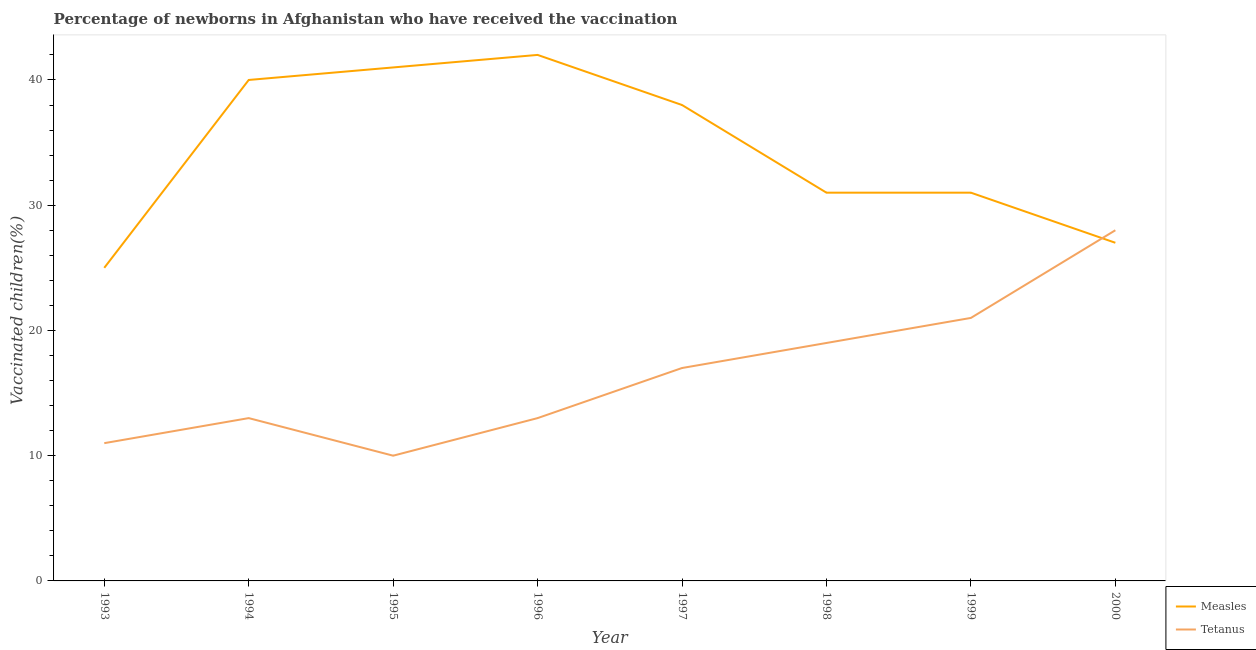Does the line corresponding to percentage of newborns who received vaccination for tetanus intersect with the line corresponding to percentage of newborns who received vaccination for measles?
Make the answer very short. Yes. Is the number of lines equal to the number of legend labels?
Ensure brevity in your answer.  Yes. What is the percentage of newborns who received vaccination for measles in 1999?
Ensure brevity in your answer.  31. Across all years, what is the maximum percentage of newborns who received vaccination for tetanus?
Offer a terse response. 28. Across all years, what is the minimum percentage of newborns who received vaccination for measles?
Give a very brief answer. 25. What is the total percentage of newborns who received vaccination for tetanus in the graph?
Offer a terse response. 132. What is the difference between the percentage of newborns who received vaccination for measles in 1993 and that in 1997?
Ensure brevity in your answer.  -13. What is the difference between the percentage of newborns who received vaccination for measles in 1993 and the percentage of newborns who received vaccination for tetanus in 2000?
Provide a succinct answer. -3. What is the average percentage of newborns who received vaccination for tetanus per year?
Offer a very short reply. 16.5. In the year 1994, what is the difference between the percentage of newborns who received vaccination for measles and percentage of newborns who received vaccination for tetanus?
Give a very brief answer. 27. What is the ratio of the percentage of newborns who received vaccination for tetanus in 1994 to that in 1996?
Give a very brief answer. 1. Is the difference between the percentage of newborns who received vaccination for measles in 1994 and 1995 greater than the difference between the percentage of newborns who received vaccination for tetanus in 1994 and 1995?
Offer a terse response. No. What is the difference between the highest and the second highest percentage of newborns who received vaccination for tetanus?
Your answer should be very brief. 7. What is the difference between the highest and the lowest percentage of newborns who received vaccination for tetanus?
Your response must be concise. 18. Is the sum of the percentage of newborns who received vaccination for tetanus in 1998 and 1999 greater than the maximum percentage of newborns who received vaccination for measles across all years?
Give a very brief answer. No. Does the percentage of newborns who received vaccination for measles monotonically increase over the years?
Keep it short and to the point. No. How many years are there in the graph?
Ensure brevity in your answer.  8. What is the difference between two consecutive major ticks on the Y-axis?
Make the answer very short. 10. Does the graph contain any zero values?
Give a very brief answer. No. How many legend labels are there?
Keep it short and to the point. 2. How are the legend labels stacked?
Your response must be concise. Vertical. What is the title of the graph?
Your answer should be very brief. Percentage of newborns in Afghanistan who have received the vaccination. Does "Male labourers" appear as one of the legend labels in the graph?
Ensure brevity in your answer.  No. What is the label or title of the Y-axis?
Provide a short and direct response. Vaccinated children(%)
. What is the Vaccinated children(%)
 in Measles in 1993?
Your response must be concise. 25. What is the Vaccinated children(%)
 in Tetanus in 1994?
Your response must be concise. 13. What is the Vaccinated children(%)
 in Measles in 1995?
Give a very brief answer. 41. What is the Vaccinated children(%)
 of Tetanus in 1995?
Your answer should be compact. 10. What is the Vaccinated children(%)
 of Tetanus in 1996?
Offer a terse response. 13. What is the Vaccinated children(%)
 in Measles in 1997?
Provide a succinct answer. 38. What is the Vaccinated children(%)
 of Measles in 1998?
Your response must be concise. 31. What is the Vaccinated children(%)
 in Tetanus in 1998?
Provide a succinct answer. 19. What is the Vaccinated children(%)
 in Measles in 1999?
Your response must be concise. 31. What is the Vaccinated children(%)
 of Tetanus in 1999?
Provide a short and direct response. 21. What is the Vaccinated children(%)
 in Measles in 2000?
Ensure brevity in your answer.  27. Across all years, what is the maximum Vaccinated children(%)
 of Measles?
Your answer should be very brief. 42. Across all years, what is the minimum Vaccinated children(%)
 in Tetanus?
Give a very brief answer. 10. What is the total Vaccinated children(%)
 in Measles in the graph?
Give a very brief answer. 275. What is the total Vaccinated children(%)
 of Tetanus in the graph?
Keep it short and to the point. 132. What is the difference between the Vaccinated children(%)
 in Tetanus in 1993 and that in 1994?
Give a very brief answer. -2. What is the difference between the Vaccinated children(%)
 in Tetanus in 1993 and that in 1995?
Give a very brief answer. 1. What is the difference between the Vaccinated children(%)
 of Tetanus in 1993 and that in 1997?
Your answer should be compact. -6. What is the difference between the Vaccinated children(%)
 of Measles in 1993 and that in 1998?
Offer a very short reply. -6. What is the difference between the Vaccinated children(%)
 of Measles in 1994 and that in 1995?
Give a very brief answer. -1. What is the difference between the Vaccinated children(%)
 in Measles in 1994 and that in 1996?
Give a very brief answer. -2. What is the difference between the Vaccinated children(%)
 of Tetanus in 1994 and that in 1996?
Ensure brevity in your answer.  0. What is the difference between the Vaccinated children(%)
 in Measles in 1994 and that in 1997?
Your response must be concise. 2. What is the difference between the Vaccinated children(%)
 in Tetanus in 1994 and that in 1997?
Make the answer very short. -4. What is the difference between the Vaccinated children(%)
 in Measles in 1994 and that in 1998?
Ensure brevity in your answer.  9. What is the difference between the Vaccinated children(%)
 of Tetanus in 1994 and that in 1998?
Provide a short and direct response. -6. What is the difference between the Vaccinated children(%)
 of Tetanus in 1994 and that in 1999?
Provide a succinct answer. -8. What is the difference between the Vaccinated children(%)
 in Measles in 1994 and that in 2000?
Your answer should be compact. 13. What is the difference between the Vaccinated children(%)
 of Tetanus in 1995 and that in 1996?
Make the answer very short. -3. What is the difference between the Vaccinated children(%)
 of Measles in 1995 and that in 1998?
Ensure brevity in your answer.  10. What is the difference between the Vaccinated children(%)
 in Tetanus in 1995 and that in 1998?
Make the answer very short. -9. What is the difference between the Vaccinated children(%)
 of Tetanus in 1995 and that in 1999?
Your response must be concise. -11. What is the difference between the Vaccinated children(%)
 of Measles in 1995 and that in 2000?
Provide a succinct answer. 14. What is the difference between the Vaccinated children(%)
 of Measles in 1996 and that in 1997?
Make the answer very short. 4. What is the difference between the Vaccinated children(%)
 in Tetanus in 1996 and that in 1997?
Keep it short and to the point. -4. What is the difference between the Vaccinated children(%)
 in Measles in 1996 and that in 1998?
Provide a short and direct response. 11. What is the difference between the Vaccinated children(%)
 of Tetanus in 1996 and that in 1998?
Your answer should be compact. -6. What is the difference between the Vaccinated children(%)
 of Measles in 1996 and that in 1999?
Your answer should be compact. 11. What is the difference between the Vaccinated children(%)
 of Tetanus in 1996 and that in 1999?
Your answer should be compact. -8. What is the difference between the Vaccinated children(%)
 in Measles in 1996 and that in 2000?
Give a very brief answer. 15. What is the difference between the Vaccinated children(%)
 of Tetanus in 1996 and that in 2000?
Your answer should be very brief. -15. What is the difference between the Vaccinated children(%)
 of Measles in 1997 and that in 1998?
Keep it short and to the point. 7. What is the difference between the Vaccinated children(%)
 of Tetanus in 1997 and that in 1998?
Your response must be concise. -2. What is the difference between the Vaccinated children(%)
 in Measles in 1997 and that in 1999?
Your answer should be compact. 7. What is the difference between the Vaccinated children(%)
 in Tetanus in 1997 and that in 1999?
Provide a succinct answer. -4. What is the difference between the Vaccinated children(%)
 of Measles in 1997 and that in 2000?
Ensure brevity in your answer.  11. What is the difference between the Vaccinated children(%)
 in Tetanus in 1997 and that in 2000?
Ensure brevity in your answer.  -11. What is the difference between the Vaccinated children(%)
 of Measles in 1998 and that in 1999?
Your answer should be compact. 0. What is the difference between the Vaccinated children(%)
 of Tetanus in 1998 and that in 1999?
Provide a short and direct response. -2. What is the difference between the Vaccinated children(%)
 of Tetanus in 1998 and that in 2000?
Keep it short and to the point. -9. What is the difference between the Vaccinated children(%)
 of Tetanus in 1999 and that in 2000?
Make the answer very short. -7. What is the difference between the Vaccinated children(%)
 of Measles in 1993 and the Vaccinated children(%)
 of Tetanus in 1994?
Ensure brevity in your answer.  12. What is the difference between the Vaccinated children(%)
 in Measles in 1994 and the Vaccinated children(%)
 in Tetanus in 1996?
Your response must be concise. 27. What is the difference between the Vaccinated children(%)
 of Measles in 1994 and the Vaccinated children(%)
 of Tetanus in 1997?
Your response must be concise. 23. What is the difference between the Vaccinated children(%)
 in Measles in 1994 and the Vaccinated children(%)
 in Tetanus in 1998?
Make the answer very short. 21. What is the difference between the Vaccinated children(%)
 in Measles in 1994 and the Vaccinated children(%)
 in Tetanus in 1999?
Your answer should be compact. 19. What is the difference between the Vaccinated children(%)
 of Measles in 1994 and the Vaccinated children(%)
 of Tetanus in 2000?
Provide a short and direct response. 12. What is the difference between the Vaccinated children(%)
 in Measles in 1995 and the Vaccinated children(%)
 in Tetanus in 1998?
Keep it short and to the point. 22. What is the difference between the Vaccinated children(%)
 in Measles in 1995 and the Vaccinated children(%)
 in Tetanus in 2000?
Provide a succinct answer. 13. What is the difference between the Vaccinated children(%)
 in Measles in 1996 and the Vaccinated children(%)
 in Tetanus in 1997?
Provide a short and direct response. 25. What is the difference between the Vaccinated children(%)
 in Measles in 1996 and the Vaccinated children(%)
 in Tetanus in 1998?
Your response must be concise. 23. What is the difference between the Vaccinated children(%)
 of Measles in 1997 and the Vaccinated children(%)
 of Tetanus in 1998?
Make the answer very short. 19. What is the difference between the Vaccinated children(%)
 in Measles in 1998 and the Vaccinated children(%)
 in Tetanus in 1999?
Your answer should be compact. 10. What is the average Vaccinated children(%)
 in Measles per year?
Offer a terse response. 34.38. What is the average Vaccinated children(%)
 in Tetanus per year?
Make the answer very short. 16.5. In the year 1995, what is the difference between the Vaccinated children(%)
 of Measles and Vaccinated children(%)
 of Tetanus?
Your answer should be compact. 31. In the year 1996, what is the difference between the Vaccinated children(%)
 in Measles and Vaccinated children(%)
 in Tetanus?
Your answer should be very brief. 29. In the year 1997, what is the difference between the Vaccinated children(%)
 of Measles and Vaccinated children(%)
 of Tetanus?
Make the answer very short. 21. What is the ratio of the Vaccinated children(%)
 in Tetanus in 1993 to that in 1994?
Offer a terse response. 0.85. What is the ratio of the Vaccinated children(%)
 of Measles in 1993 to that in 1995?
Ensure brevity in your answer.  0.61. What is the ratio of the Vaccinated children(%)
 in Measles in 1993 to that in 1996?
Your answer should be very brief. 0.6. What is the ratio of the Vaccinated children(%)
 in Tetanus in 1993 to that in 1996?
Provide a short and direct response. 0.85. What is the ratio of the Vaccinated children(%)
 in Measles in 1993 to that in 1997?
Your response must be concise. 0.66. What is the ratio of the Vaccinated children(%)
 of Tetanus in 1993 to that in 1997?
Ensure brevity in your answer.  0.65. What is the ratio of the Vaccinated children(%)
 of Measles in 1993 to that in 1998?
Make the answer very short. 0.81. What is the ratio of the Vaccinated children(%)
 in Tetanus in 1993 to that in 1998?
Make the answer very short. 0.58. What is the ratio of the Vaccinated children(%)
 in Measles in 1993 to that in 1999?
Your response must be concise. 0.81. What is the ratio of the Vaccinated children(%)
 of Tetanus in 1993 to that in 1999?
Your answer should be compact. 0.52. What is the ratio of the Vaccinated children(%)
 of Measles in 1993 to that in 2000?
Provide a short and direct response. 0.93. What is the ratio of the Vaccinated children(%)
 of Tetanus in 1993 to that in 2000?
Provide a succinct answer. 0.39. What is the ratio of the Vaccinated children(%)
 in Measles in 1994 to that in 1995?
Ensure brevity in your answer.  0.98. What is the ratio of the Vaccinated children(%)
 of Tetanus in 1994 to that in 1995?
Make the answer very short. 1.3. What is the ratio of the Vaccinated children(%)
 of Tetanus in 1994 to that in 1996?
Your response must be concise. 1. What is the ratio of the Vaccinated children(%)
 in Measles in 1994 to that in 1997?
Give a very brief answer. 1.05. What is the ratio of the Vaccinated children(%)
 in Tetanus in 1994 to that in 1997?
Give a very brief answer. 0.76. What is the ratio of the Vaccinated children(%)
 in Measles in 1994 to that in 1998?
Offer a very short reply. 1.29. What is the ratio of the Vaccinated children(%)
 of Tetanus in 1994 to that in 1998?
Keep it short and to the point. 0.68. What is the ratio of the Vaccinated children(%)
 in Measles in 1994 to that in 1999?
Your response must be concise. 1.29. What is the ratio of the Vaccinated children(%)
 of Tetanus in 1994 to that in 1999?
Make the answer very short. 0.62. What is the ratio of the Vaccinated children(%)
 in Measles in 1994 to that in 2000?
Your answer should be very brief. 1.48. What is the ratio of the Vaccinated children(%)
 in Tetanus in 1994 to that in 2000?
Offer a terse response. 0.46. What is the ratio of the Vaccinated children(%)
 of Measles in 1995 to that in 1996?
Make the answer very short. 0.98. What is the ratio of the Vaccinated children(%)
 of Tetanus in 1995 to that in 1996?
Provide a succinct answer. 0.77. What is the ratio of the Vaccinated children(%)
 of Measles in 1995 to that in 1997?
Keep it short and to the point. 1.08. What is the ratio of the Vaccinated children(%)
 in Tetanus in 1995 to that in 1997?
Your answer should be compact. 0.59. What is the ratio of the Vaccinated children(%)
 of Measles in 1995 to that in 1998?
Your response must be concise. 1.32. What is the ratio of the Vaccinated children(%)
 of Tetanus in 1995 to that in 1998?
Give a very brief answer. 0.53. What is the ratio of the Vaccinated children(%)
 in Measles in 1995 to that in 1999?
Ensure brevity in your answer.  1.32. What is the ratio of the Vaccinated children(%)
 of Tetanus in 1995 to that in 1999?
Keep it short and to the point. 0.48. What is the ratio of the Vaccinated children(%)
 of Measles in 1995 to that in 2000?
Provide a short and direct response. 1.52. What is the ratio of the Vaccinated children(%)
 in Tetanus in 1995 to that in 2000?
Your answer should be very brief. 0.36. What is the ratio of the Vaccinated children(%)
 in Measles in 1996 to that in 1997?
Your answer should be compact. 1.11. What is the ratio of the Vaccinated children(%)
 of Tetanus in 1996 to that in 1997?
Ensure brevity in your answer.  0.76. What is the ratio of the Vaccinated children(%)
 of Measles in 1996 to that in 1998?
Your response must be concise. 1.35. What is the ratio of the Vaccinated children(%)
 in Tetanus in 1996 to that in 1998?
Your answer should be compact. 0.68. What is the ratio of the Vaccinated children(%)
 of Measles in 1996 to that in 1999?
Provide a short and direct response. 1.35. What is the ratio of the Vaccinated children(%)
 in Tetanus in 1996 to that in 1999?
Your answer should be compact. 0.62. What is the ratio of the Vaccinated children(%)
 of Measles in 1996 to that in 2000?
Give a very brief answer. 1.56. What is the ratio of the Vaccinated children(%)
 in Tetanus in 1996 to that in 2000?
Provide a succinct answer. 0.46. What is the ratio of the Vaccinated children(%)
 of Measles in 1997 to that in 1998?
Ensure brevity in your answer.  1.23. What is the ratio of the Vaccinated children(%)
 in Tetanus in 1997 to that in 1998?
Ensure brevity in your answer.  0.89. What is the ratio of the Vaccinated children(%)
 of Measles in 1997 to that in 1999?
Provide a succinct answer. 1.23. What is the ratio of the Vaccinated children(%)
 of Tetanus in 1997 to that in 1999?
Offer a terse response. 0.81. What is the ratio of the Vaccinated children(%)
 of Measles in 1997 to that in 2000?
Offer a very short reply. 1.41. What is the ratio of the Vaccinated children(%)
 in Tetanus in 1997 to that in 2000?
Keep it short and to the point. 0.61. What is the ratio of the Vaccinated children(%)
 in Tetanus in 1998 to that in 1999?
Offer a terse response. 0.9. What is the ratio of the Vaccinated children(%)
 in Measles in 1998 to that in 2000?
Your answer should be very brief. 1.15. What is the ratio of the Vaccinated children(%)
 in Tetanus in 1998 to that in 2000?
Provide a succinct answer. 0.68. What is the ratio of the Vaccinated children(%)
 in Measles in 1999 to that in 2000?
Your response must be concise. 1.15. What is the difference between the highest and the second highest Vaccinated children(%)
 of Measles?
Offer a terse response. 1. What is the difference between the highest and the second highest Vaccinated children(%)
 of Tetanus?
Your answer should be compact. 7. What is the difference between the highest and the lowest Vaccinated children(%)
 of Measles?
Your answer should be very brief. 17. 